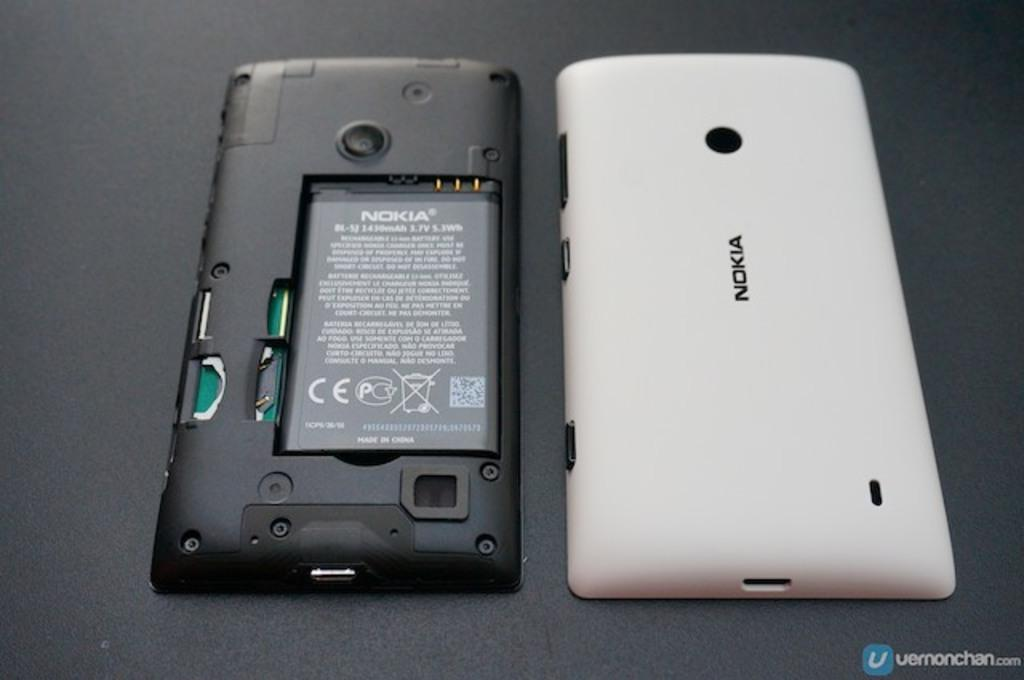Provide a one-sentence caption for the provided image. A phone from Nokia with the back remove and place to its side. 